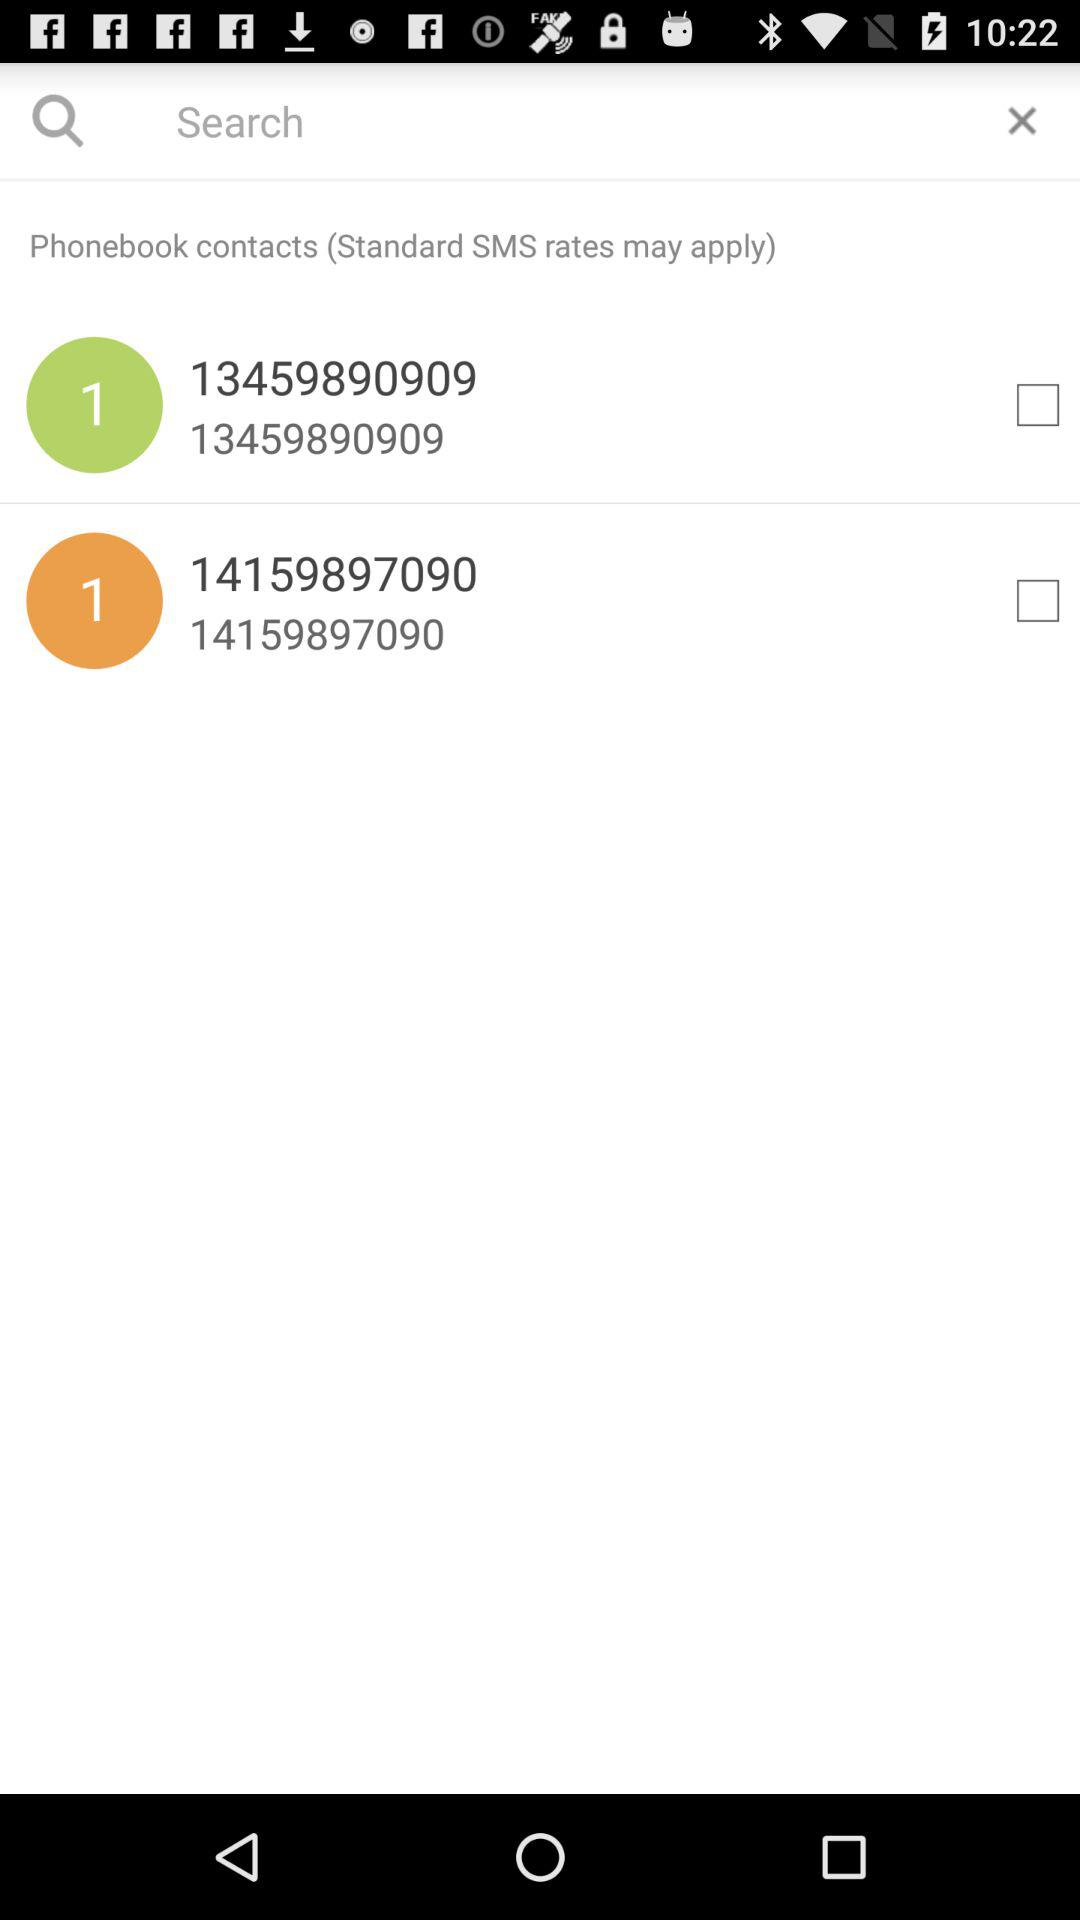How many checkboxes are present?
Answer the question using a single word or phrase. 2 